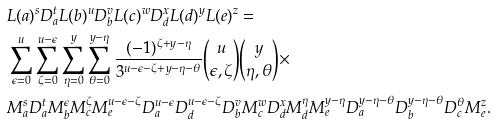Convert formula to latex. <formula><loc_0><loc_0><loc_500><loc_500>& L ( a ) ^ { s } D _ { a } ^ { t } L ( b ) ^ { u } D _ { b } ^ { v } L ( c ) ^ { w } D _ { d } ^ { x } L ( d ) ^ { y } L ( e ) ^ { z } = \\ & \sum _ { \epsilon = 0 } ^ { u } \sum _ { \zeta = 0 } ^ { u - \epsilon } \sum _ { \eta = 0 } ^ { y } \sum _ { \theta = 0 } ^ { y - \eta } \frac { ( - 1 ) ^ { \zeta + y - \eta } } { 3 ^ { u - \epsilon - \zeta + y - \eta - \theta } } \binom { u } { \epsilon , \zeta } \binom { y } { \eta , \theta } \times \\ & M _ { a } ^ { s } D _ { a } ^ { t } M _ { b } ^ { \epsilon } M _ { c } ^ { \zeta } M _ { e } ^ { u - \epsilon - \zeta } D _ { a } ^ { u - \epsilon } D _ { d } ^ { u - \epsilon - \zeta } D _ { b } ^ { v } M _ { c } ^ { w } D _ { d } ^ { x } M _ { d } ^ { \eta } M _ { e } ^ { y - \eta } D _ { a } ^ { y - \eta - \theta } D _ { b } ^ { y - \eta - \theta } D _ { c } ^ { \theta } M _ { e } ^ { z } .</formula> 